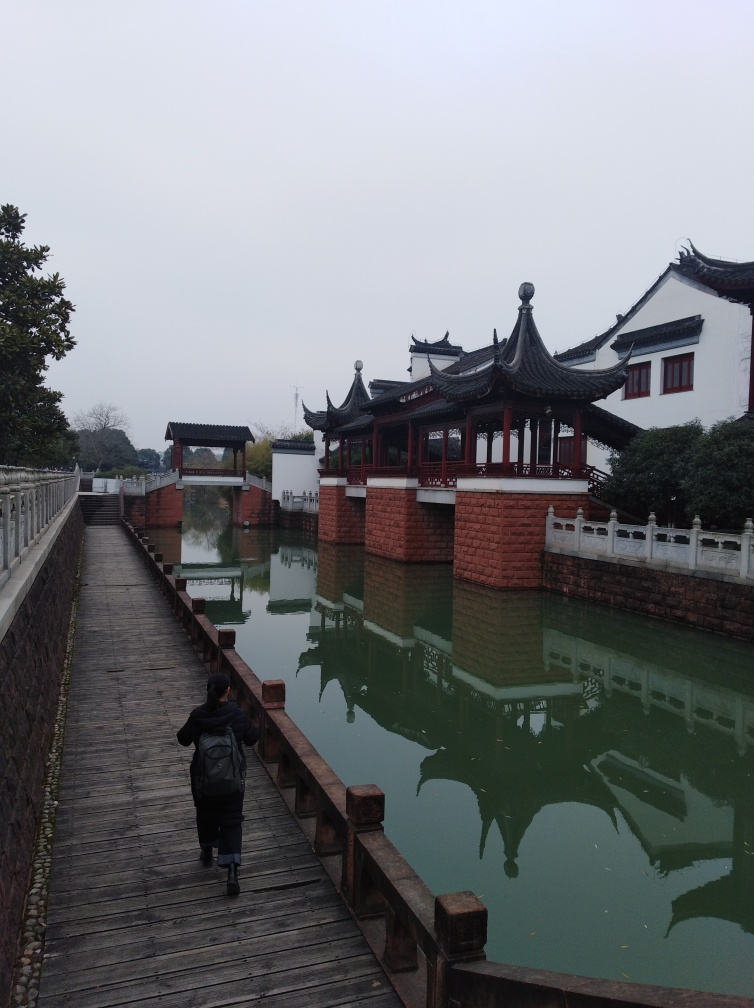What is the focus like in the image?
A. Accurate
B. Out of focus
C. Fuzzy The image's focus is quite accurate, capturing the details clearly from the foreground where we see a person walking on the wooden bridge to the traditional architecture in the background. The reflections on the calm water surface are sharp, indicating a well-adjusted depth of field to maintain clarity across various distances. 